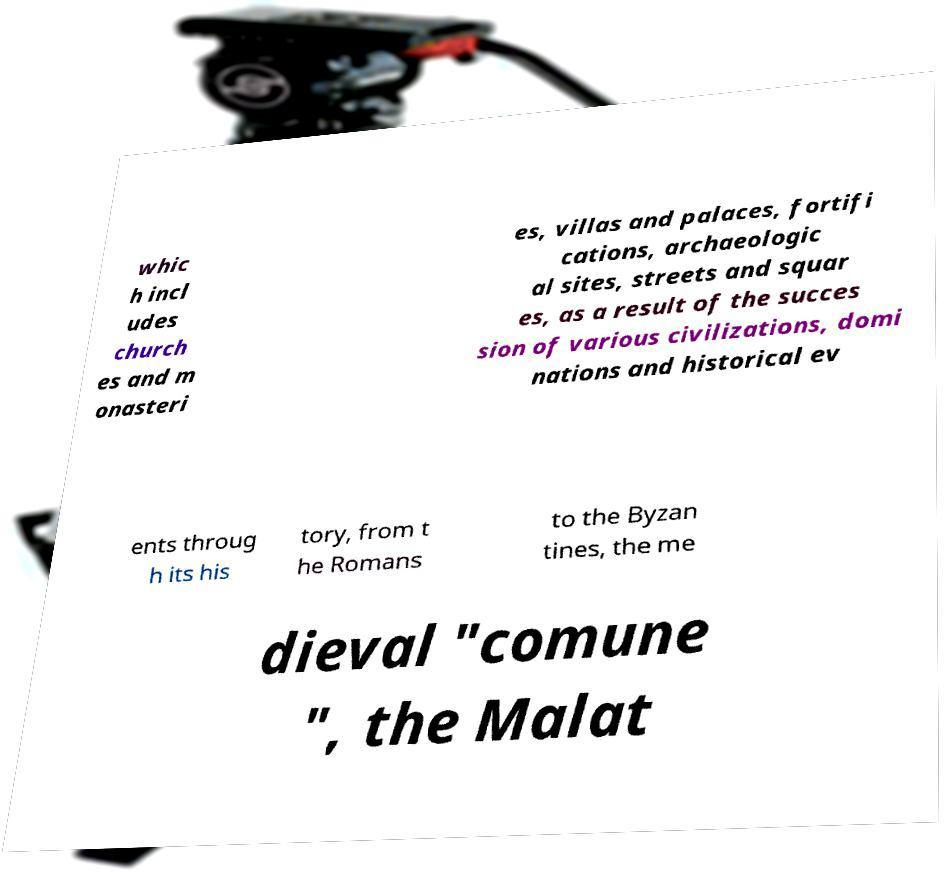Please identify and transcribe the text found in this image. whic h incl udes church es and m onasteri es, villas and palaces, fortifi cations, archaeologic al sites, streets and squar es, as a result of the succes sion of various civilizations, domi nations and historical ev ents throug h its his tory, from t he Romans to the Byzan tines, the me dieval "comune ", the Malat 